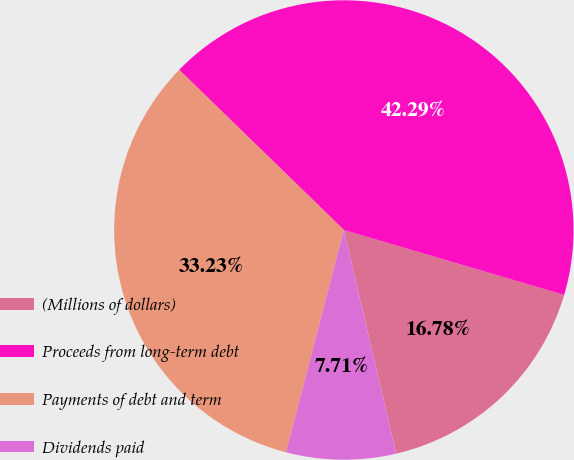Convert chart to OTSL. <chart><loc_0><loc_0><loc_500><loc_500><pie_chart><fcel>(Millions of dollars)<fcel>Proceeds from long-term debt<fcel>Payments of debt and term<fcel>Dividends paid<nl><fcel>16.78%<fcel>42.29%<fcel>33.23%<fcel>7.71%<nl></chart> 